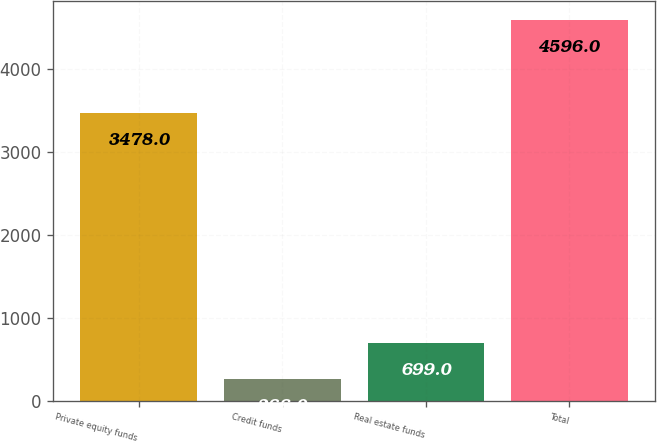<chart> <loc_0><loc_0><loc_500><loc_500><bar_chart><fcel>Private equity funds<fcel>Credit funds<fcel>Real estate funds<fcel>Total<nl><fcel>3478<fcel>266<fcel>699<fcel>4596<nl></chart> 